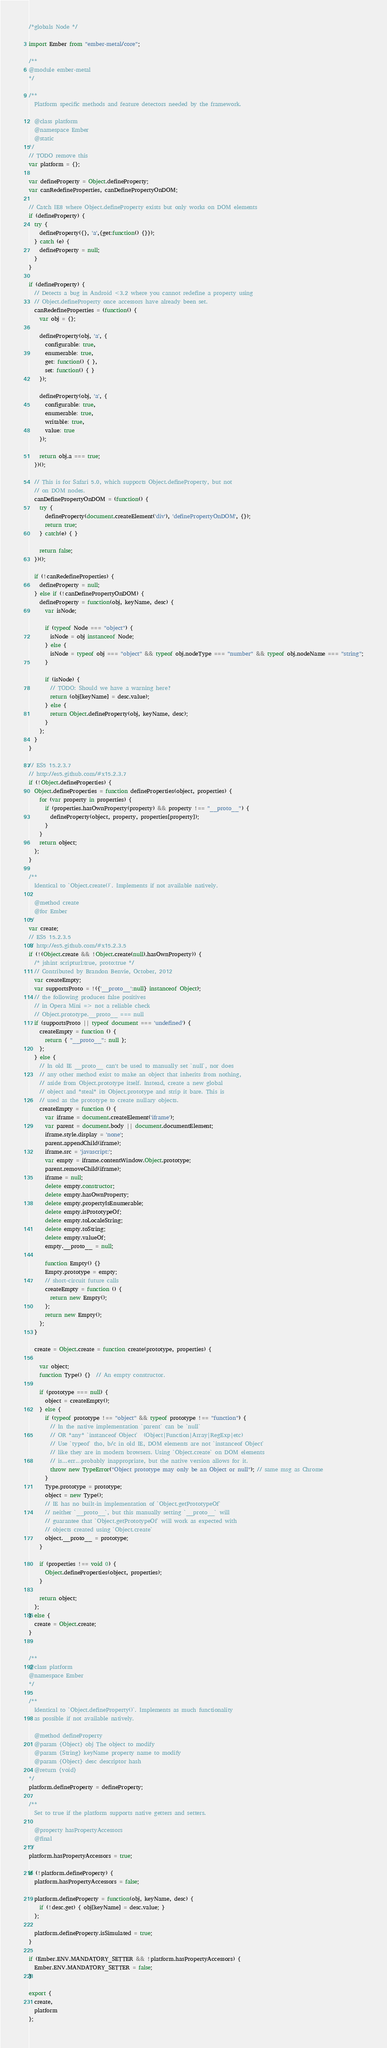<code> <loc_0><loc_0><loc_500><loc_500><_JavaScript_>/*globals Node */

import Ember from "ember-metal/core";

/**
@module ember-metal
*/

/**
  Platform specific methods and feature detectors needed by the framework.

  @class platform
  @namespace Ember
  @static
*/
// TODO remove this
var platform = {};

var defineProperty = Object.defineProperty;
var canRedefineProperties, canDefinePropertyOnDOM;

// Catch IE8 where Object.defineProperty exists but only works on DOM elements
if (defineProperty) {
  try {
    defineProperty({}, 'a',{get:function() {}});
  } catch (e) {
    defineProperty = null;
  }
}

if (defineProperty) {
  // Detects a bug in Android <3.2 where you cannot redefine a property using
  // Object.defineProperty once accessors have already been set.
  canRedefineProperties = (function() {
    var obj = {};

    defineProperty(obj, 'a', {
      configurable: true,
      enumerable: true,
      get: function() { },
      set: function() { }
    });

    defineProperty(obj, 'a', {
      configurable: true,
      enumerable: true,
      writable: true,
      value: true
    });

    return obj.a === true;
  })();

  // This is for Safari 5.0, which supports Object.defineProperty, but not
  // on DOM nodes.
  canDefinePropertyOnDOM = (function() {
    try {
      defineProperty(document.createElement('div'), 'definePropertyOnDOM', {});
      return true;
    } catch(e) { }

    return false;
  })();

  if (!canRedefineProperties) {
    defineProperty = null;
  } else if (!canDefinePropertyOnDOM) {
    defineProperty = function(obj, keyName, desc) {
      var isNode;

      if (typeof Node === "object") {
        isNode = obj instanceof Node;
      } else {
        isNode = typeof obj === "object" && typeof obj.nodeType === "number" && typeof obj.nodeName === "string";
      }

      if (isNode) {
        // TODO: Should we have a warning here?
        return (obj[keyName] = desc.value);
      } else {
        return Object.defineProperty(obj, keyName, desc);
      }
    };
  }
}

// ES5 15.2.3.7
// http://es5.github.com/#x15.2.3.7
if (!Object.defineProperties) {
  Object.defineProperties = function defineProperties(object, properties) {
    for (var property in properties) {
      if (properties.hasOwnProperty(property) && property !== "__proto__") {
        defineProperty(object, property, properties[property]);
      }
    }
    return object;
  };
}

/**
  Identical to `Object.create()`. Implements if not available natively.

  @method create
  @for Ember
*/
var create;
// ES5 15.2.3.5
// http://es5.github.com/#x15.2.3.5
if (!(Object.create && !Object.create(null).hasOwnProperty)) {
  /* jshint scripturl:true, proto:true */
  // Contributed by Brandon Benvie, October, 2012
  var createEmpty;
  var supportsProto = !({'__proto__':null} instanceof Object);
  // the following produces false positives
  // in Opera Mini => not a reliable check
  // Object.prototype.__proto__ === null
  if (supportsProto || typeof document === 'undefined') {
    createEmpty = function () {
      return { "__proto__": null };
    };
  } else {
    // In old IE __proto__ can't be used to manually set `null`, nor does
    // any other method exist to make an object that inherits from nothing,
    // aside from Object.prototype itself. Instead, create a new global
    // object and *steal* its Object.prototype and strip it bare. This is
    // used as the prototype to create nullary objects.
    createEmpty = function () {
      var iframe = document.createElement('iframe');
      var parent = document.body || document.documentElement;
      iframe.style.display = 'none';
      parent.appendChild(iframe);
      iframe.src = 'javascript:';
      var empty = iframe.contentWindow.Object.prototype;
      parent.removeChild(iframe);
      iframe = null;
      delete empty.constructor;
      delete empty.hasOwnProperty;
      delete empty.propertyIsEnumerable;
      delete empty.isPrototypeOf;
      delete empty.toLocaleString;
      delete empty.toString;
      delete empty.valueOf;
      empty.__proto__ = null;

      function Empty() {}
      Empty.prototype = empty;
      // short-circuit future calls
      createEmpty = function () {
        return new Empty();
      };
      return new Empty();
    };
  }

  create = Object.create = function create(prototype, properties) {

    var object;
    function Type() {}  // An empty constructor.

    if (prototype === null) {
      object = createEmpty();
    } else {
      if (typeof prototype !== "object" && typeof prototype !== "function") {
        // In the native implementation `parent` can be `null`
        // OR *any* `instanceof Object`  (Object|Function|Array|RegExp|etc)
        // Use `typeof` tho, b/c in old IE, DOM elements are not `instanceof Object`
        // like they are in modern browsers. Using `Object.create` on DOM elements
        // is...err...probably inappropriate, but the native version allows for it.
        throw new TypeError("Object prototype may only be an Object or null"); // same msg as Chrome
      }
      Type.prototype = prototype;
      object = new Type();
      // IE has no built-in implementation of `Object.getPrototypeOf`
      // neither `__proto__`, but this manually setting `__proto__` will
      // guarantee that `Object.getPrototypeOf` will work as expected with
      // objects created using `Object.create`
      object.__proto__ = prototype;
    }

    if (properties !== void 0) {
      Object.defineProperties(object, properties);
    }

    return object;
  };
} else {
  create = Object.create;
}


/**
@class platform
@namespace Ember
*/

/**
  Identical to `Object.defineProperty()`. Implements as much functionality
  as possible if not available natively.

  @method defineProperty
  @param {Object} obj The object to modify
  @param {String} keyName property name to modify
  @param {Object} desc descriptor hash
  @return {void}
*/
platform.defineProperty = defineProperty;

/**
  Set to true if the platform supports native getters and setters.

  @property hasPropertyAccessors
  @final
*/
platform.hasPropertyAccessors = true;

if (!platform.defineProperty) {
  platform.hasPropertyAccessors = false;

  platform.defineProperty = function(obj, keyName, desc) {
    if (!desc.get) { obj[keyName] = desc.value; }
  };

  platform.defineProperty.isSimulated = true;
}

if (Ember.ENV.MANDATORY_SETTER && !platform.hasPropertyAccessors) {
  Ember.ENV.MANDATORY_SETTER = false;
}

export {
  create,
  platform
};
</code> 